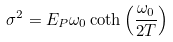<formula> <loc_0><loc_0><loc_500><loc_500>\sigma ^ { 2 } = E _ { P } \omega _ { 0 } \coth \left ( \frac { \omega _ { 0 } } { 2 T } \right )</formula> 